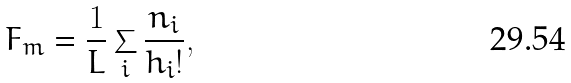<formula> <loc_0><loc_0><loc_500><loc_500>F _ { m } = \frac { 1 } { L } \sum _ { i } \frac { n _ { i } } { h _ { i } ! } ,</formula> 